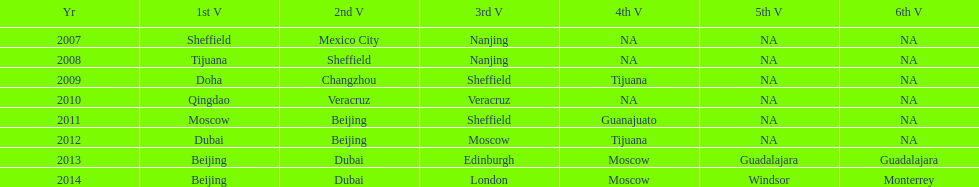Which two venue has no nations from 2007-2012 5th Venue, 6th Venue. 